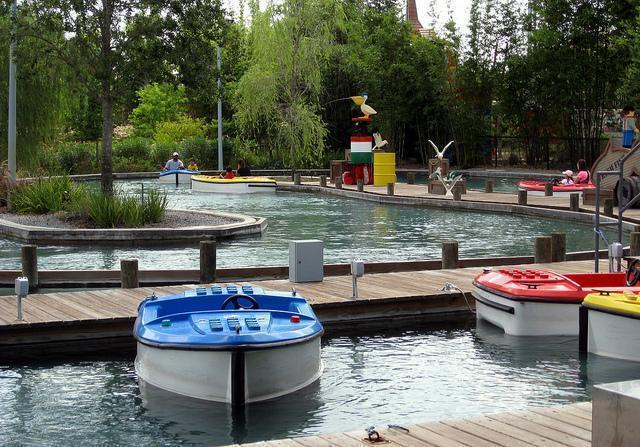What type of bird is on the red white and green barrel?
From the following set of four choices, select the accurate answer to respond to the question.
Options: Eagle, swan, pelican, rooster. Pelican. 